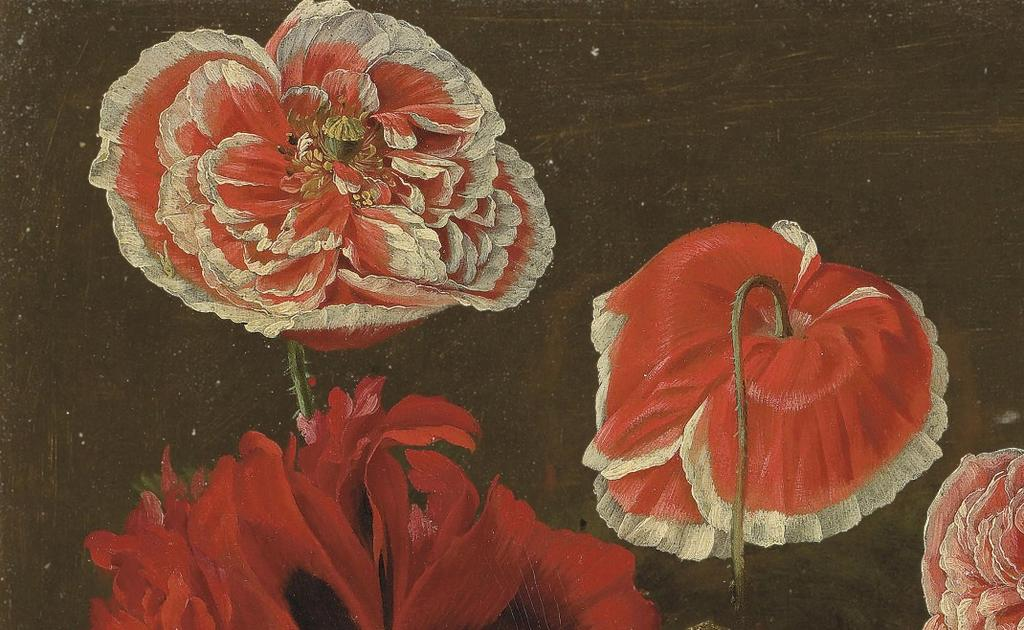What type of artwork is shown in the image? The image appears to be a painting. What is the main subject of the painting? There are flowers depicted in the image. How would you describe the overall color scheme of the painting? The background of the image is dark. How does the salt affect the flowers in the image? There is no salt present in the image, so it cannot affect the flowers. 